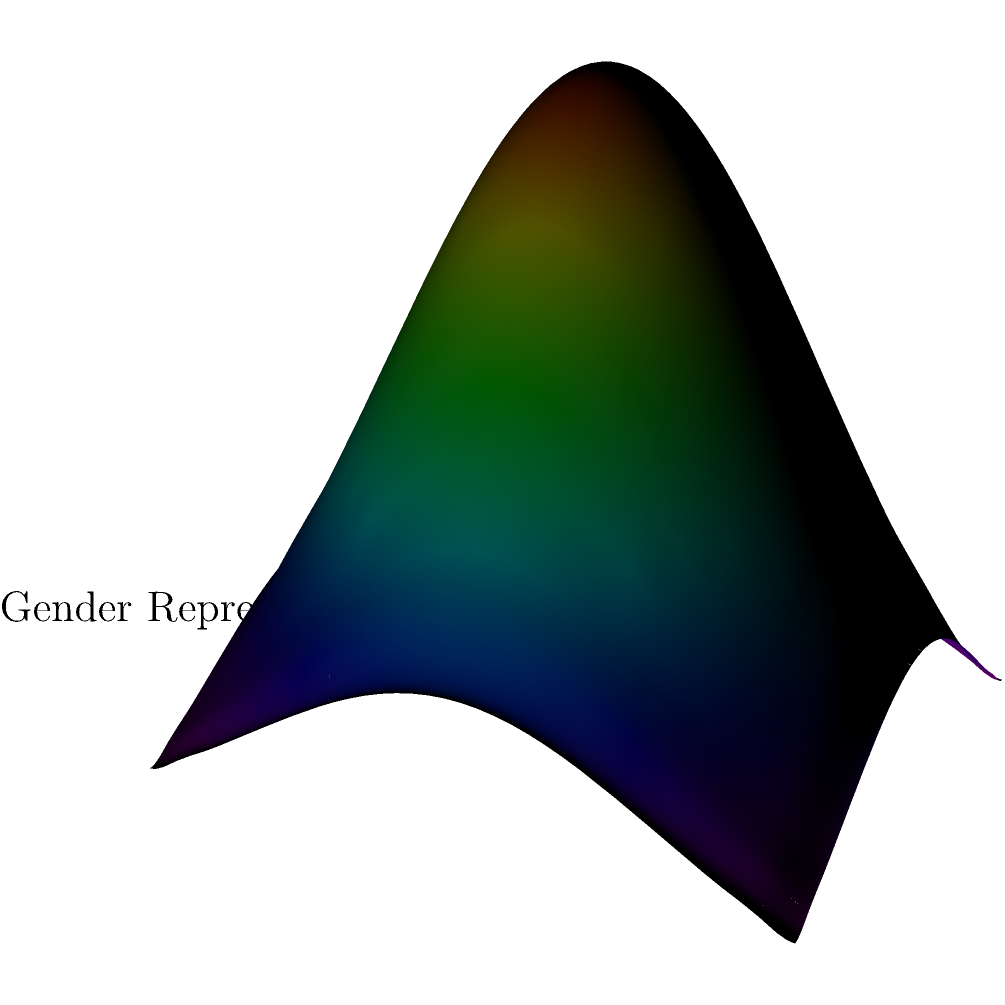Consider the multi-variable function graph representing gender representation in STEM fields over time. At the point $(0.5, 0.5, z)$, which represents the midpoint of both STEM fields and time, calculate the rate of change of gender representation with respect to time (y-axis) while holding the STEM field constant. Express your answer in terms of the partial derivative $\frac{\partial z}{\partial y}$. To solve this problem, we need to follow these steps:

1) The given function is of the form:
   $z = 0.8 \cdot e^{-((x-0.5)^2+(y-0.5)^2)/0.2}$

2) We need to find $\frac{\partial z}{\partial y}$ at the point (0.5, 0.5, z).

3) First, let's calculate the partial derivative:
   $\frac{\partial z}{\partial y} = 0.8 \cdot e^{-((x-0.5)^2+(y-0.5)^2)/0.2} \cdot \frac{-2(y-0.5)}{0.2}$

4) Simplify:
   $\frac{\partial z}{\partial y} = -8(y-0.5) \cdot e^{-((x-0.5)^2+(y-0.5)^2)/0.2}$

5) Now, we evaluate this at the point (0.5, 0.5, z):
   At x = 0.5 and y = 0.5, we have:
   $\frac{\partial z}{\partial y} = -8(0.5-0.5) \cdot e^{-(0^2+0^2)/0.2}$

6) Simplify:
   $\frac{\partial z}{\partial y} = -8(0) \cdot e^0 = 0$

Therefore, at the point (0.5, 0.5, z), the rate of change of gender representation with respect to time, while holding the STEM field constant, is 0.
Answer: $\frac{\partial z}{\partial y} = 0$ 